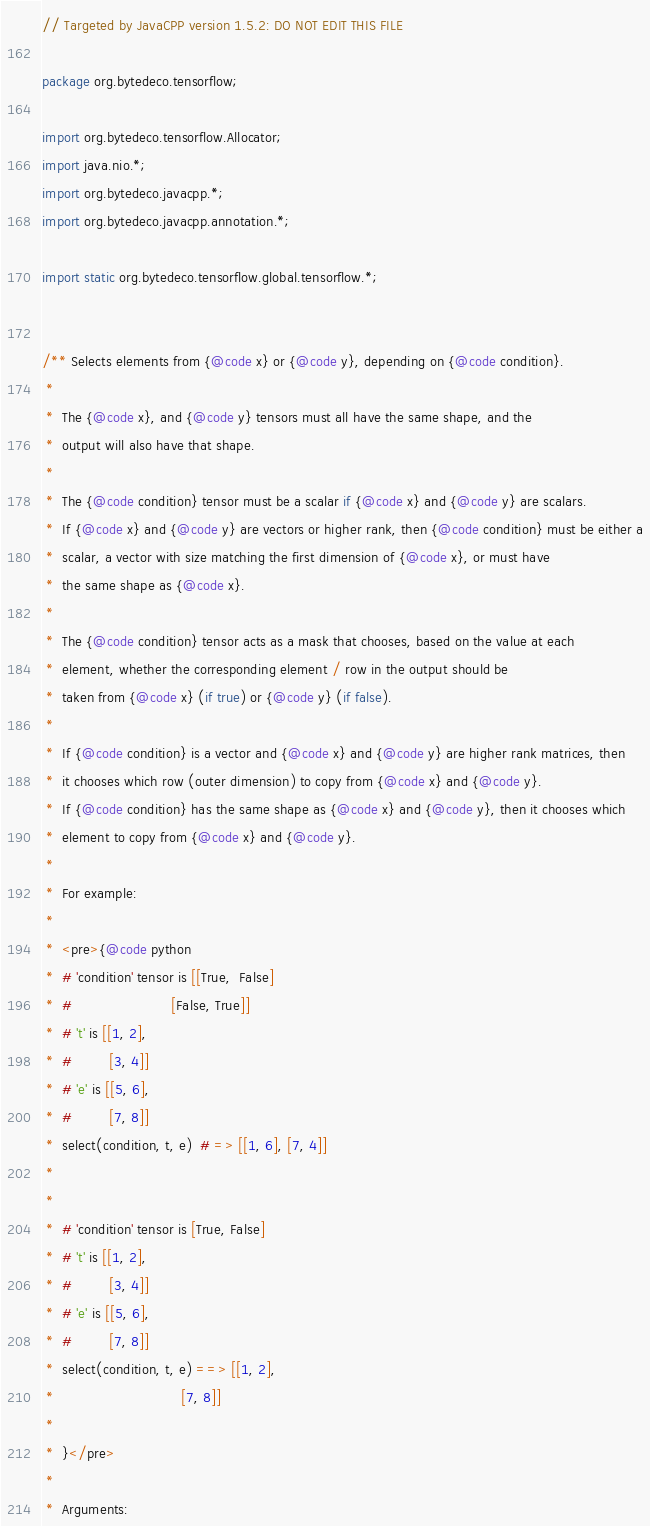<code> <loc_0><loc_0><loc_500><loc_500><_Java_>// Targeted by JavaCPP version 1.5.2: DO NOT EDIT THIS FILE

package org.bytedeco.tensorflow;

import org.bytedeco.tensorflow.Allocator;
import java.nio.*;
import org.bytedeco.javacpp.*;
import org.bytedeco.javacpp.annotation.*;

import static org.bytedeco.tensorflow.global.tensorflow.*;


/** Selects elements from {@code x} or {@code y}, depending on {@code condition}.
 * 
 *  The {@code x}, and {@code y} tensors must all have the same shape, and the
 *  output will also have that shape.
 * 
 *  The {@code condition} tensor must be a scalar if {@code x} and {@code y} are scalars.
 *  If {@code x} and {@code y} are vectors or higher rank, then {@code condition} must be either a
 *  scalar, a vector with size matching the first dimension of {@code x}, or must have
 *  the same shape as {@code x}.
 * 
 *  The {@code condition} tensor acts as a mask that chooses, based on the value at each
 *  element, whether the corresponding element / row in the output should be
 *  taken from {@code x} (if true) or {@code y} (if false).
 * 
 *  If {@code condition} is a vector and {@code x} and {@code y} are higher rank matrices, then
 *  it chooses which row (outer dimension) to copy from {@code x} and {@code y}.
 *  If {@code condition} has the same shape as {@code x} and {@code y}, then it chooses which
 *  element to copy from {@code x} and {@code y}.
 * 
 *  For example:
 * 
 *  <pre>{@code python
 *  # 'condition' tensor is [[True,  False]
 *  #                        [False, True]]
 *  # 't' is [[1, 2],
 *  #         [3, 4]]
 *  # 'e' is [[5, 6],
 *  #         [7, 8]]
 *  select(condition, t, e)  # => [[1, 6], [7, 4]]
 * 
 * 
 *  # 'condition' tensor is [True, False]
 *  # 't' is [[1, 2],
 *  #         [3, 4]]
 *  # 'e' is [[5, 6],
 *  #         [7, 8]]
 *  select(condition, t, e) ==> [[1, 2],
 *                               [7, 8]]
 * 
 *  }</pre>
 * 
 *  Arguments:</code> 